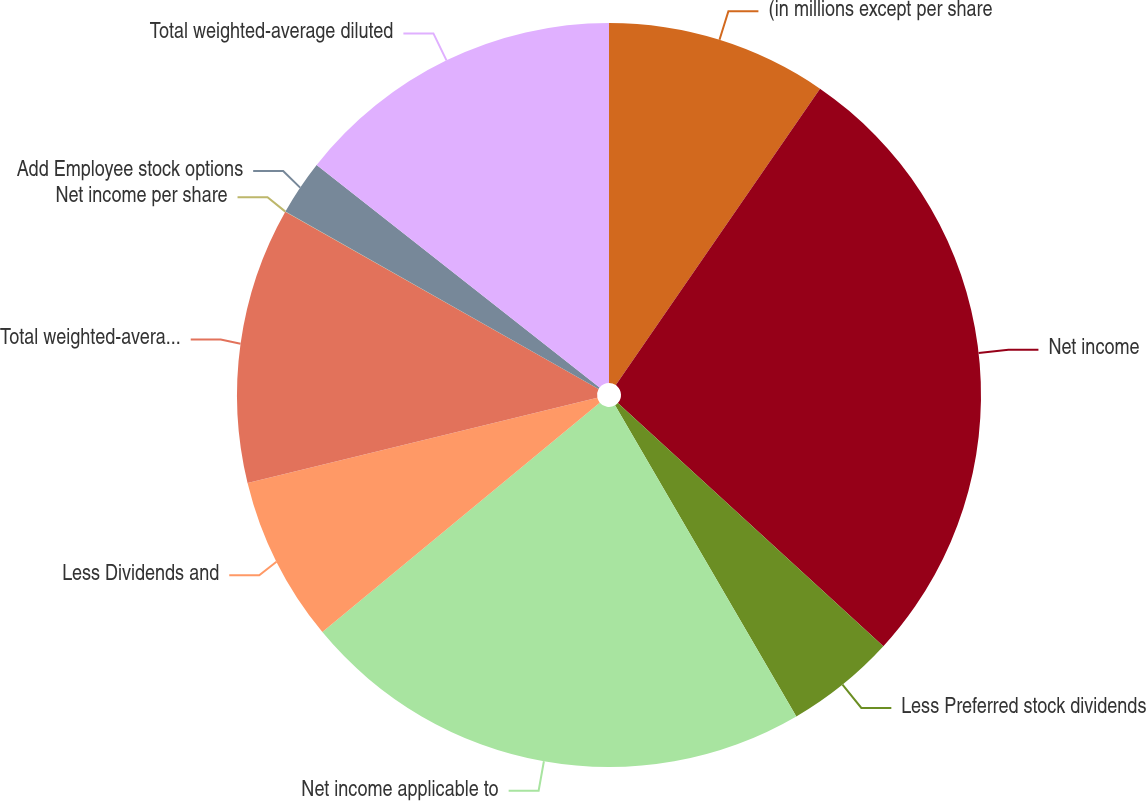<chart> <loc_0><loc_0><loc_500><loc_500><pie_chart><fcel>(in millions except per share<fcel>Net income<fcel>Less Preferred stock dividends<fcel>Net income applicable to<fcel>Less Dividends and<fcel>Total weighted-average basic<fcel>Net income per share<fcel>Add Employee stock options<fcel>Total weighted-average diluted<nl><fcel>9.6%<fcel>27.2%<fcel>4.8%<fcel>22.4%<fcel>7.2%<fcel>12.0%<fcel>0.01%<fcel>2.4%<fcel>14.39%<nl></chart> 